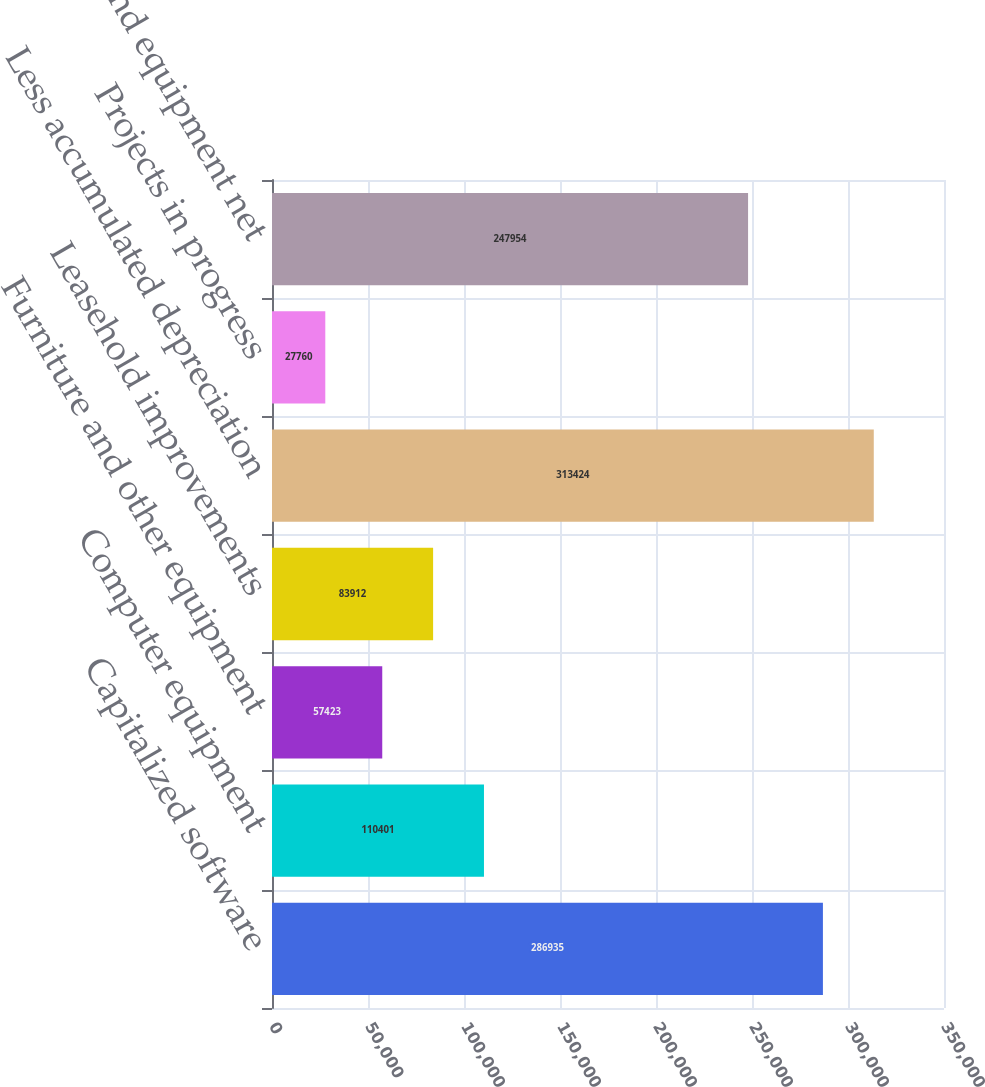Convert chart. <chart><loc_0><loc_0><loc_500><loc_500><bar_chart><fcel>Capitalized software<fcel>Computer equipment<fcel>Furniture and other equipment<fcel>Leasehold improvements<fcel>Less accumulated depreciation<fcel>Projects in progress<fcel>Property and equipment net<nl><fcel>286935<fcel>110401<fcel>57423<fcel>83912<fcel>313424<fcel>27760<fcel>247954<nl></chart> 